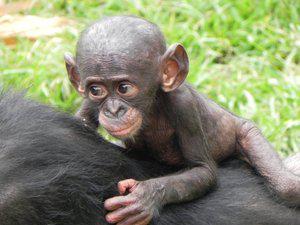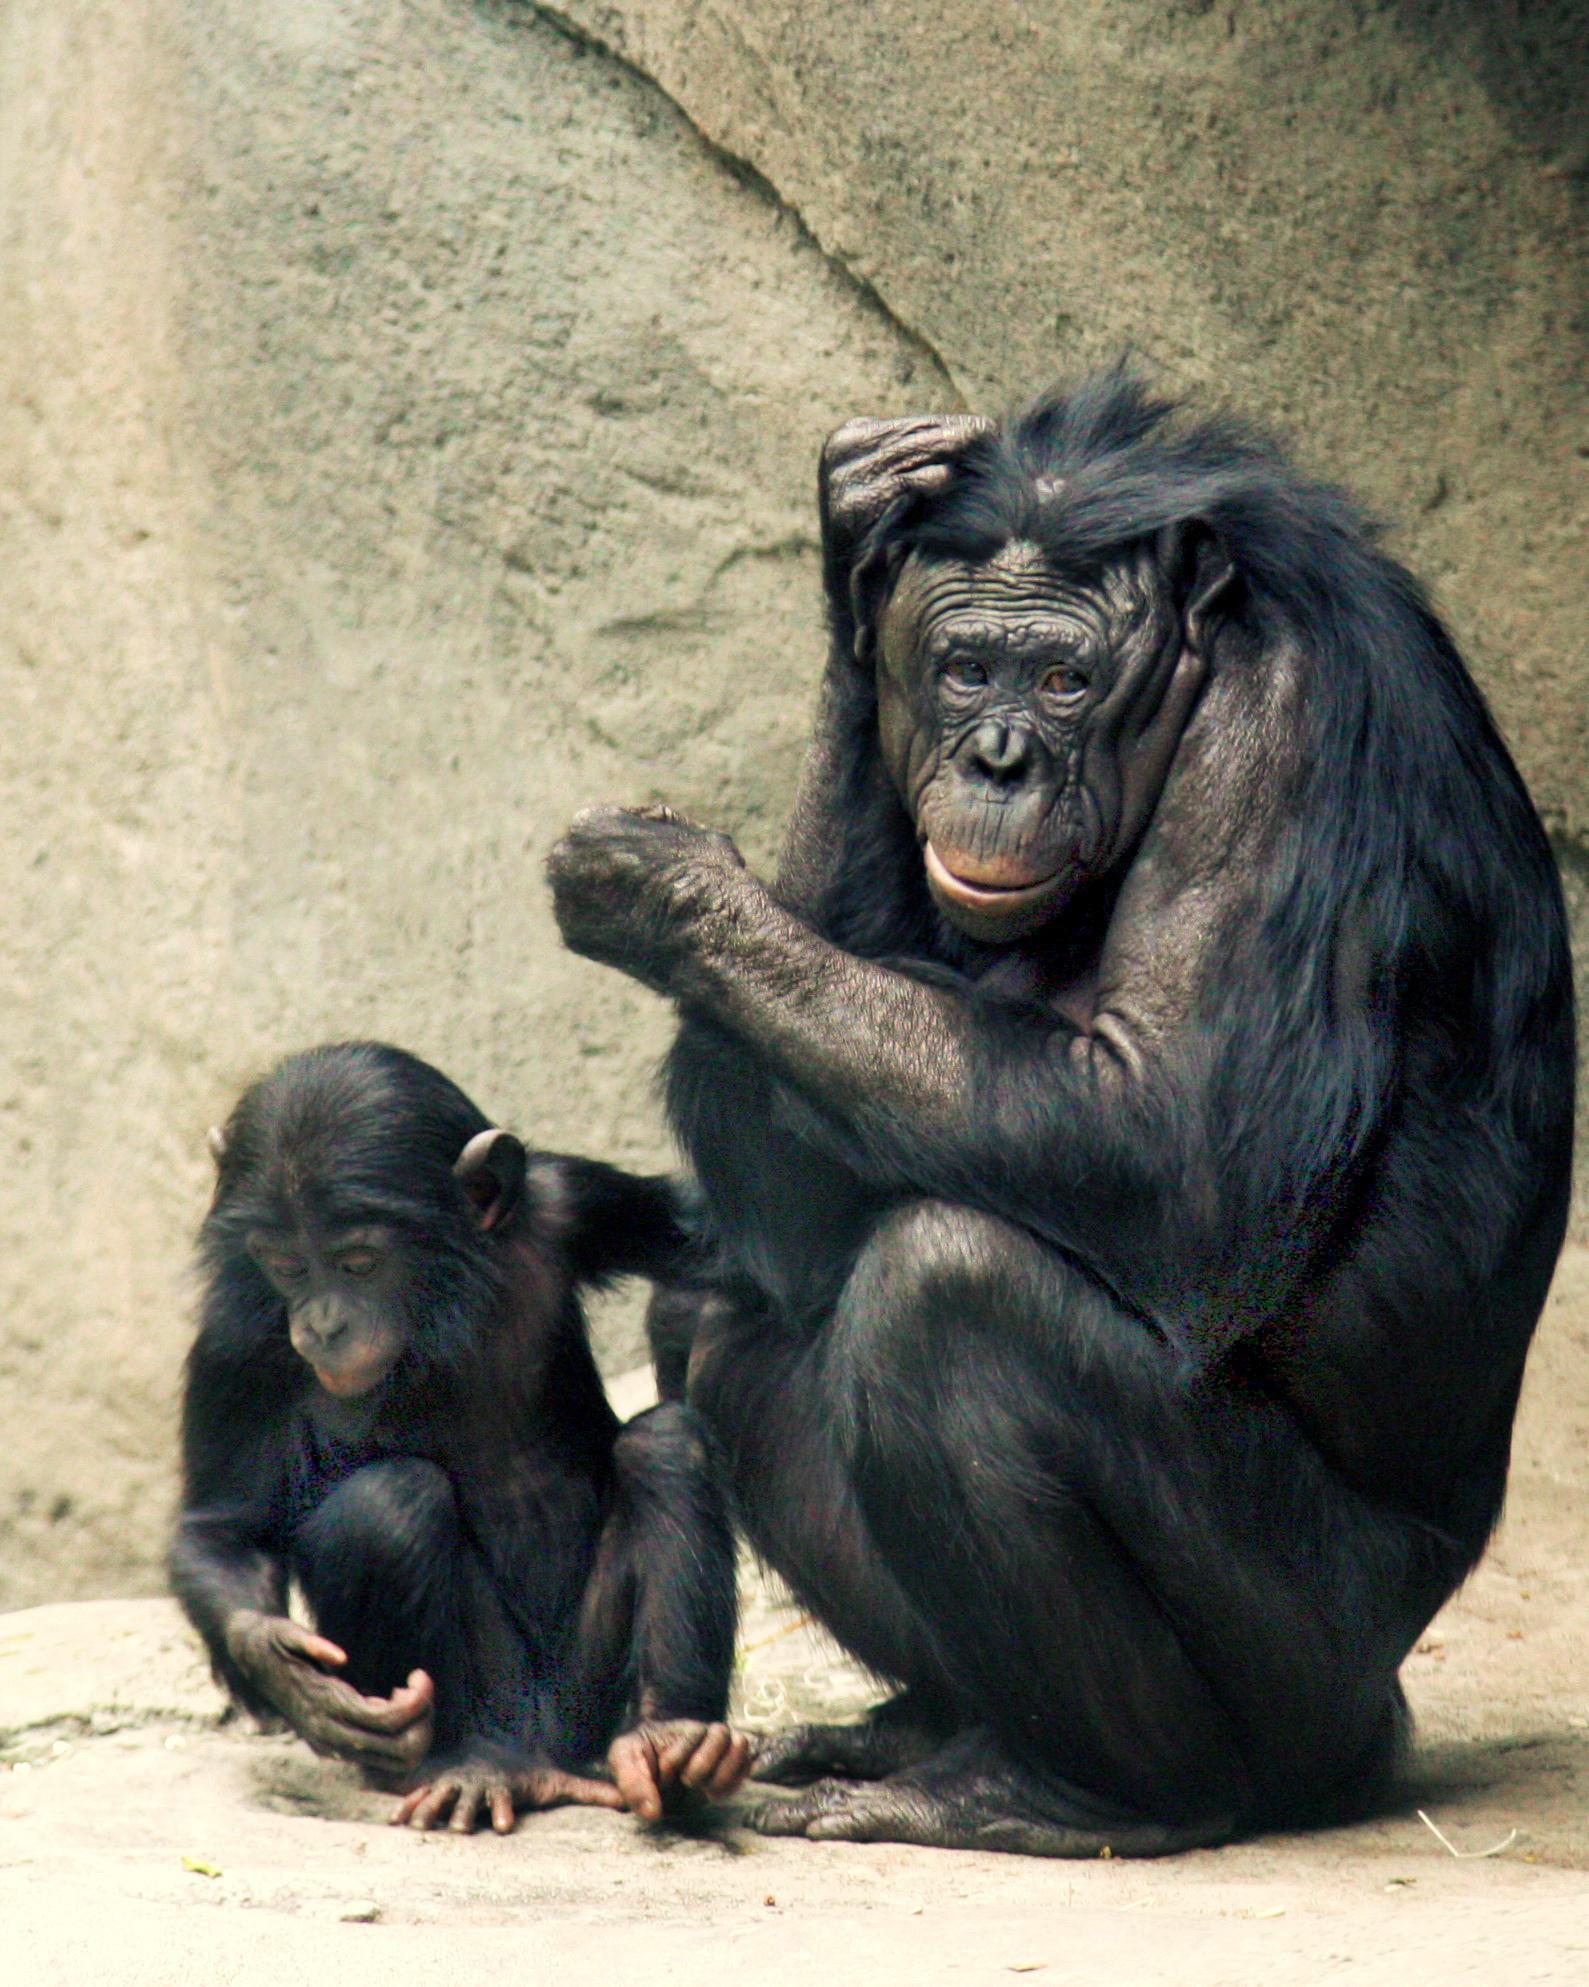The first image is the image on the left, the second image is the image on the right. Analyze the images presented: Is the assertion "The left image contains at least three chimpanzees." valid? Answer yes or no. No. The first image is the image on the left, the second image is the image on the right. Assess this claim about the two images: "The baby monkey is staying close by the adult monkey.". Correct or not? Answer yes or no. Yes. 